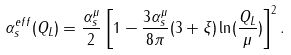<formula> <loc_0><loc_0><loc_500><loc_500>\alpha _ { s } ^ { e f f } ( Q _ { L } ) = \frac { \alpha _ { s } ^ { \mu } } { 2 } \left [ 1 - \frac { 3 \alpha _ { s } ^ { \mu } } { 8 \pi } ( 3 + \xi ) \ln ( \frac { Q _ { L } } { \mu } ) \right ] ^ { 2 } .</formula> 